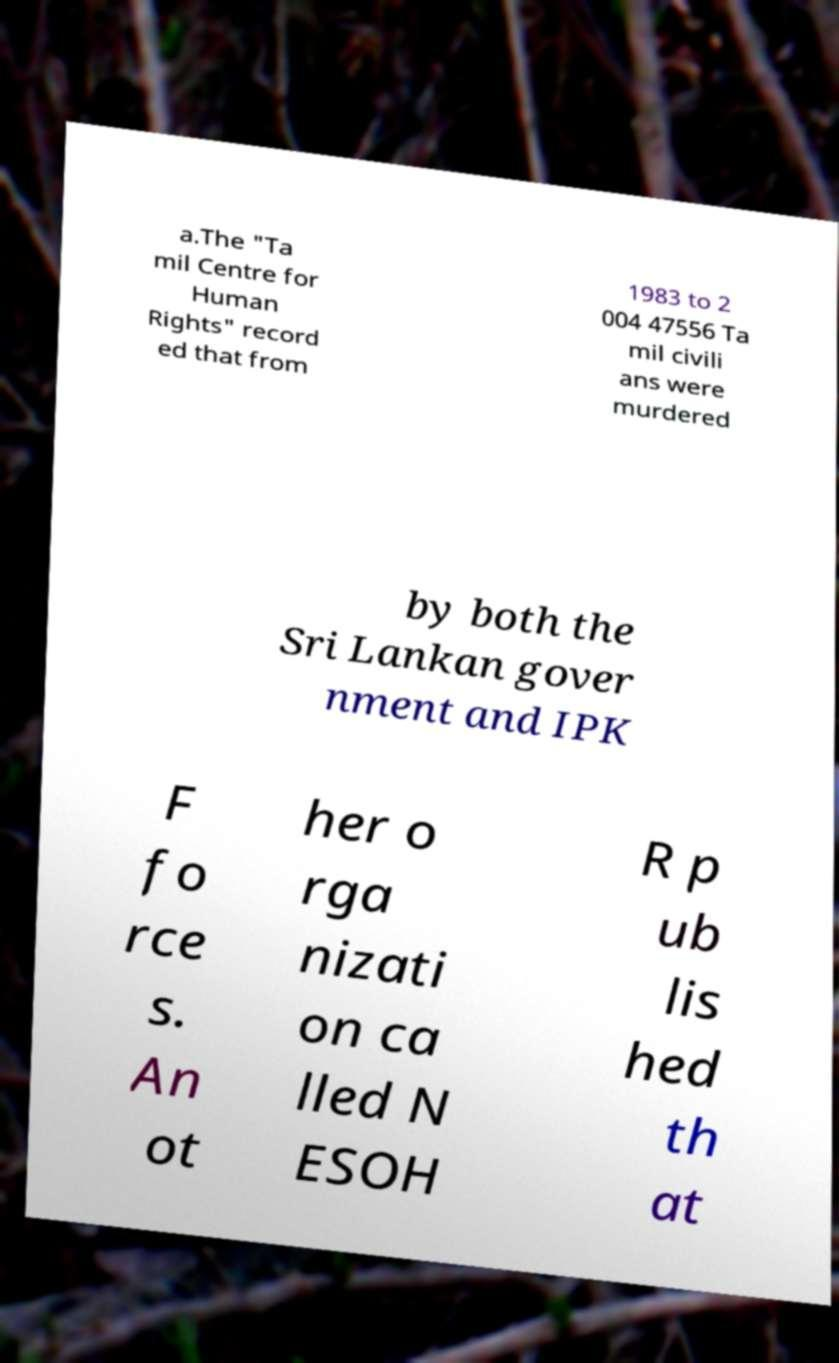Please identify and transcribe the text found in this image. a.The "Ta mil Centre for Human Rights" record ed that from 1983 to 2 004 47556 Ta mil civili ans were murdered by both the Sri Lankan gover nment and IPK F fo rce s. An ot her o rga nizati on ca lled N ESOH R p ub lis hed th at 